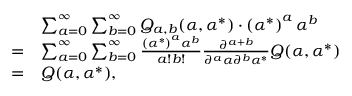<formula> <loc_0><loc_0><loc_500><loc_500>\begin{array} { r l } & { \sum _ { a = 0 } ^ { \infty } \sum _ { b = 0 } ^ { \infty } Q _ { a , b } ( \alpha , \alpha ^ { * } ) \cdot \left ( { \alpha ^ { * } } \right ) ^ { a } \alpha ^ { b } } \\ { = } & { \sum _ { a = 0 } ^ { \infty } \sum _ { b = 0 } ^ { \infty } \frac { \left ( { \alpha ^ { * } } \right ) ^ { a } \alpha ^ { b } } { a ! b ! } \frac { \partial ^ { a + b } } { \partial ^ { a } \alpha \partial ^ { b } \alpha ^ { * } } Q ( \alpha , \alpha ^ { * } ) } \\ { = } & { Q ( \alpha , \alpha ^ { * } ) , } \end{array}</formula> 